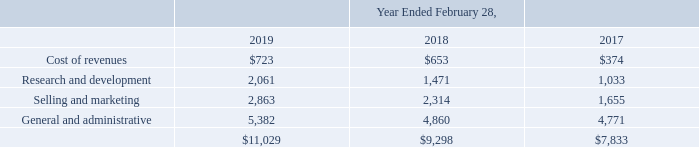Stock-based compensation expense is included in the following captions of the consolidated statements of comprehensive income (loss) (in thousands): Stock-based compensation expense is included in the following captions of the consolidated statements of comprehensive income (loss) (in thousands):
As of February 28, 2019, there was $25.5 million of unrecognized stock-based compensation cost related to non-vested equity awards, which is expected to be recognized over a weighted-average remaining vesting period of 2.8 years.
As of February 28,2019, how much unrecognized stock-based compensation cost related to non-vested equity awards were there?
Answer scale should be: million. $25.5 million. How much was the cost of revenues in 2017?
Answer scale should be: thousand. $374. How much was the cost of revenues in 2019?
Answer scale should be: thousand. $723. What was the change in Research and Development between 2018 and 2019?
Answer scale should be: thousand. (2,061-1,471)
Answer: 590. What was the change in Selling and marketing between 2018 and 2019?
Answer scale should be: thousand. (2,863-2,314)
Answer: 549. How much was General and Administrative in 2019 as a percentage of the total in 2019?
Answer scale should be: percent. (5,382/11,029)
Answer: 48.8. 